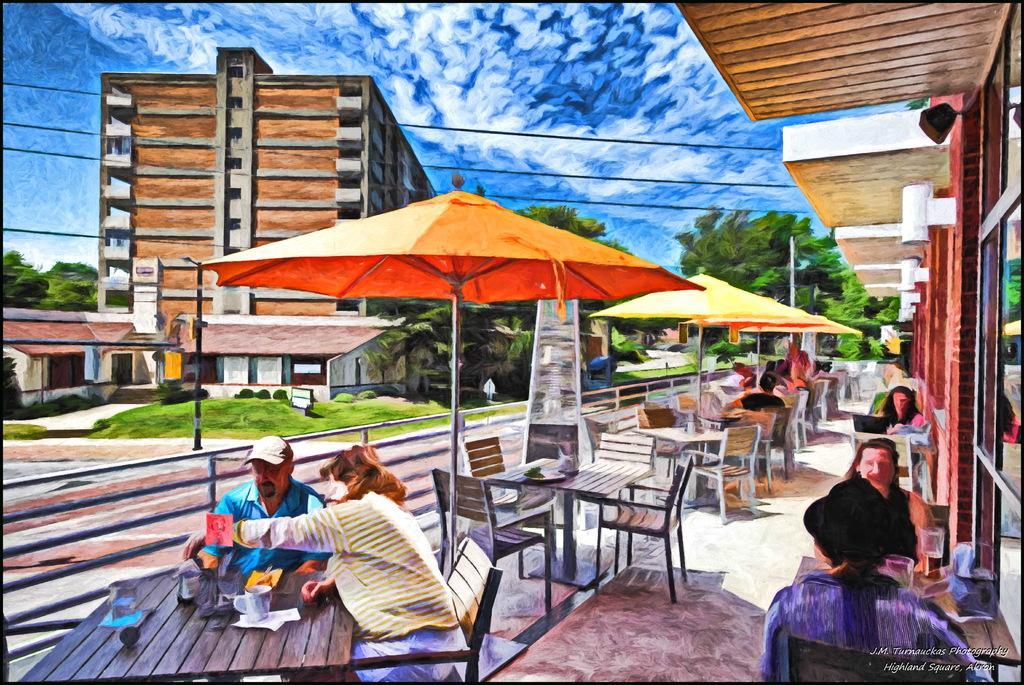Describe this image in one or two sentences. This is a picture of the city where 2 persons are sitting in the bench near the table and there is umbrella and group of person sitting in the chair and the back ground we have trees, building ,sky covered with clouds. 